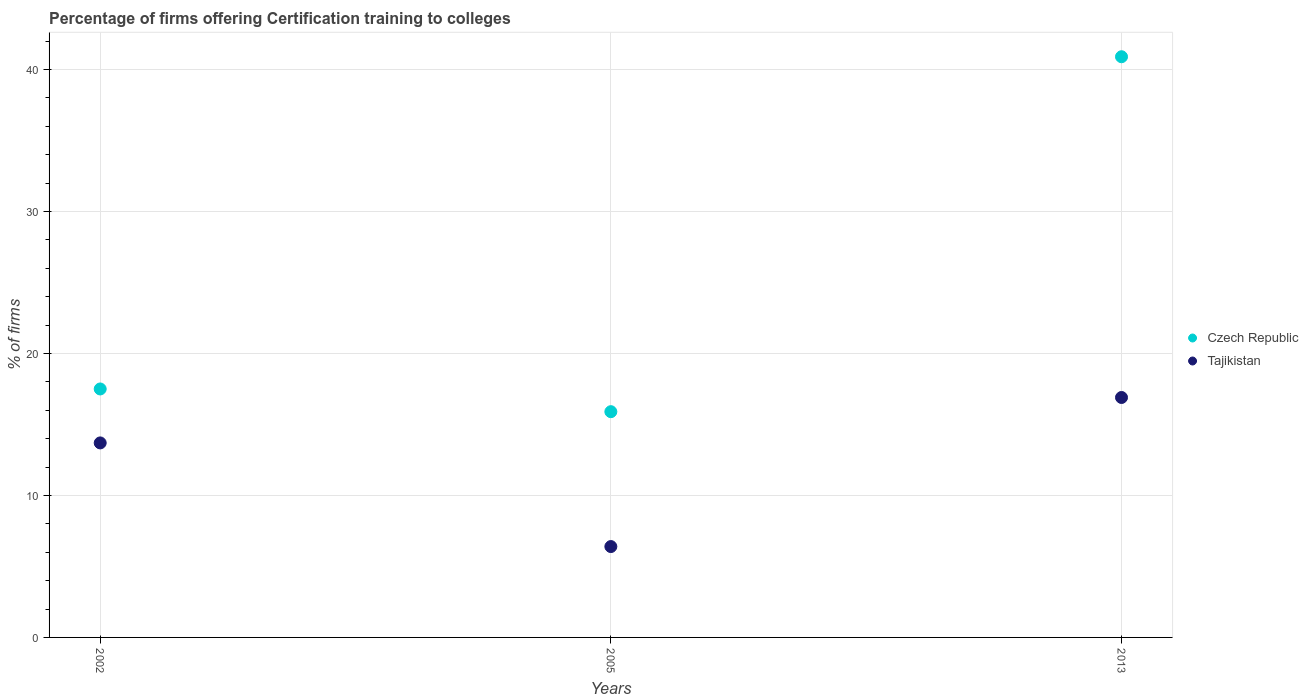How many different coloured dotlines are there?
Your answer should be very brief. 2. Across all years, what is the maximum percentage of firms offering certification training to colleges in Tajikistan?
Give a very brief answer. 16.9. What is the total percentage of firms offering certification training to colleges in Czech Republic in the graph?
Provide a succinct answer. 74.3. What is the difference between the percentage of firms offering certification training to colleges in Czech Republic in 2013 and the percentage of firms offering certification training to colleges in Tajikistan in 2005?
Provide a short and direct response. 34.5. What is the average percentage of firms offering certification training to colleges in Czech Republic per year?
Make the answer very short. 24.77. What is the ratio of the percentage of firms offering certification training to colleges in Tajikistan in 2002 to that in 2013?
Your response must be concise. 0.81. Is the percentage of firms offering certification training to colleges in Tajikistan in 2005 less than that in 2013?
Provide a short and direct response. Yes. Is the difference between the percentage of firms offering certification training to colleges in Czech Republic in 2005 and 2013 greater than the difference between the percentage of firms offering certification training to colleges in Tajikistan in 2005 and 2013?
Offer a very short reply. No. What is the difference between the highest and the second highest percentage of firms offering certification training to colleges in Tajikistan?
Ensure brevity in your answer.  3.2. Does the percentage of firms offering certification training to colleges in Tajikistan monotonically increase over the years?
Provide a succinct answer. No. Is the percentage of firms offering certification training to colleges in Tajikistan strictly less than the percentage of firms offering certification training to colleges in Czech Republic over the years?
Offer a very short reply. Yes. How many dotlines are there?
Offer a very short reply. 2. How many years are there in the graph?
Offer a terse response. 3. Does the graph contain any zero values?
Your response must be concise. No. Does the graph contain grids?
Ensure brevity in your answer.  Yes. How many legend labels are there?
Your answer should be compact. 2. What is the title of the graph?
Make the answer very short. Percentage of firms offering Certification training to colleges. What is the label or title of the Y-axis?
Provide a short and direct response. % of firms. What is the % of firms in Tajikistan in 2002?
Your answer should be very brief. 13.7. What is the % of firms in Czech Republic in 2005?
Your answer should be very brief. 15.9. What is the % of firms in Czech Republic in 2013?
Ensure brevity in your answer.  40.9. What is the % of firms of Tajikistan in 2013?
Offer a terse response. 16.9. Across all years, what is the maximum % of firms in Czech Republic?
Your response must be concise. 40.9. Across all years, what is the maximum % of firms in Tajikistan?
Provide a short and direct response. 16.9. Across all years, what is the minimum % of firms of Czech Republic?
Provide a short and direct response. 15.9. Across all years, what is the minimum % of firms of Tajikistan?
Offer a very short reply. 6.4. What is the total % of firms in Czech Republic in the graph?
Offer a terse response. 74.3. What is the total % of firms of Tajikistan in the graph?
Give a very brief answer. 37. What is the difference between the % of firms in Czech Republic in 2002 and that in 2005?
Your answer should be very brief. 1.6. What is the difference between the % of firms of Tajikistan in 2002 and that in 2005?
Provide a short and direct response. 7.3. What is the difference between the % of firms in Czech Republic in 2002 and that in 2013?
Keep it short and to the point. -23.4. What is the difference between the % of firms in Tajikistan in 2002 and that in 2013?
Make the answer very short. -3.2. What is the difference between the % of firms in Czech Republic in 2005 and the % of firms in Tajikistan in 2013?
Offer a terse response. -1. What is the average % of firms in Czech Republic per year?
Offer a very short reply. 24.77. What is the average % of firms in Tajikistan per year?
Your answer should be very brief. 12.33. In the year 2002, what is the difference between the % of firms in Czech Republic and % of firms in Tajikistan?
Your response must be concise. 3.8. What is the ratio of the % of firms of Czech Republic in 2002 to that in 2005?
Your answer should be very brief. 1.1. What is the ratio of the % of firms of Tajikistan in 2002 to that in 2005?
Provide a short and direct response. 2.14. What is the ratio of the % of firms of Czech Republic in 2002 to that in 2013?
Ensure brevity in your answer.  0.43. What is the ratio of the % of firms in Tajikistan in 2002 to that in 2013?
Your response must be concise. 0.81. What is the ratio of the % of firms of Czech Republic in 2005 to that in 2013?
Provide a short and direct response. 0.39. What is the ratio of the % of firms in Tajikistan in 2005 to that in 2013?
Your answer should be very brief. 0.38. What is the difference between the highest and the second highest % of firms in Czech Republic?
Keep it short and to the point. 23.4. What is the difference between the highest and the lowest % of firms of Tajikistan?
Provide a short and direct response. 10.5. 